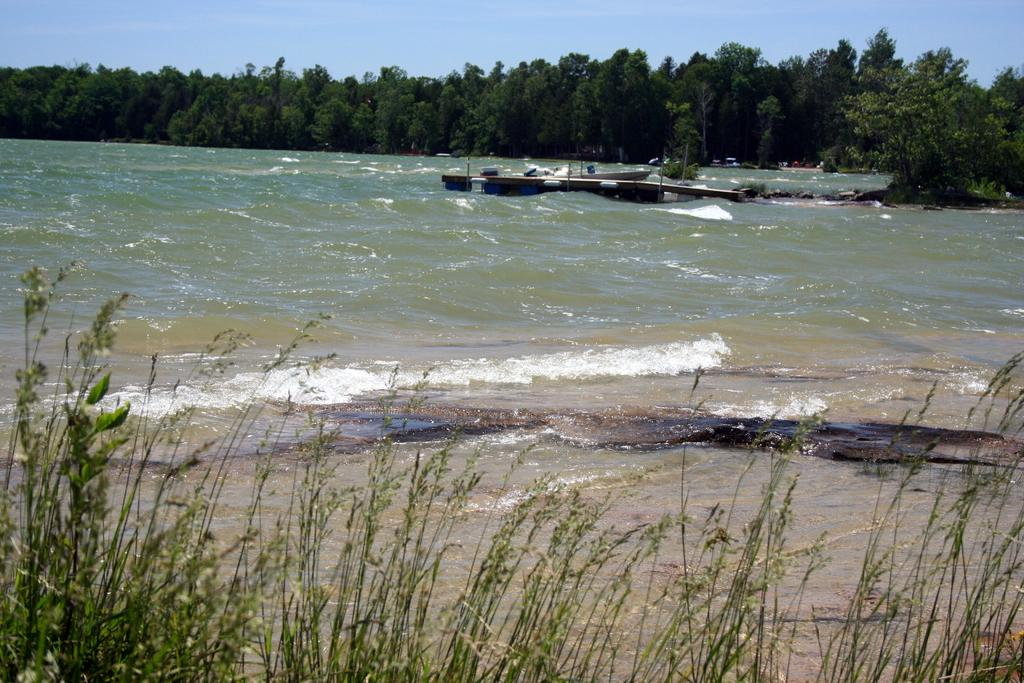What is the primary element present in the image? There is water in the image. What can be seen floating on the water? There are boats in the image. What type of vegetation is visible in the image? There are plants and trees in the image. What else can be seen in the image besides the water, boats, plants, and trees? There are some unspecified objects in the image. What is visible in the background of the image? The sky is visible in the background of the image. What arithmetic problem is being solved by the ship in the image? There is no ship present in the image, and therefore no arithmetic problem can be observed. 